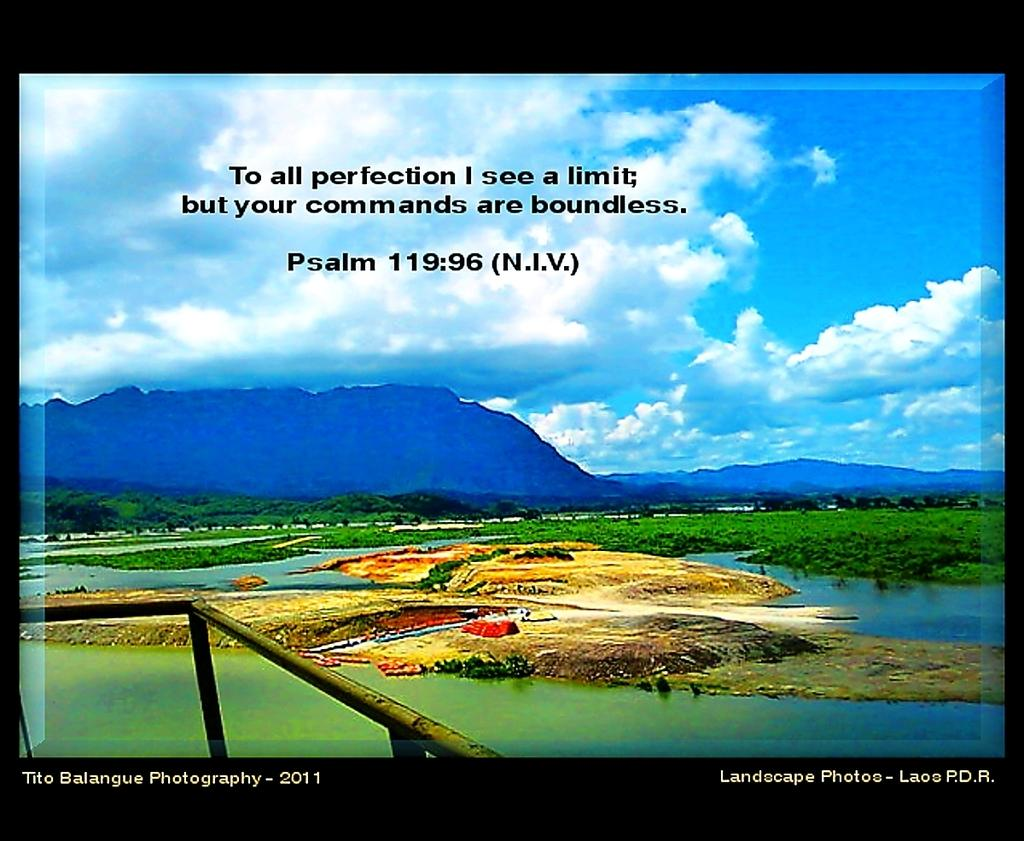Provide a one-sentence caption for the provided image. The words of a psalm are written over a colorful nature image. 